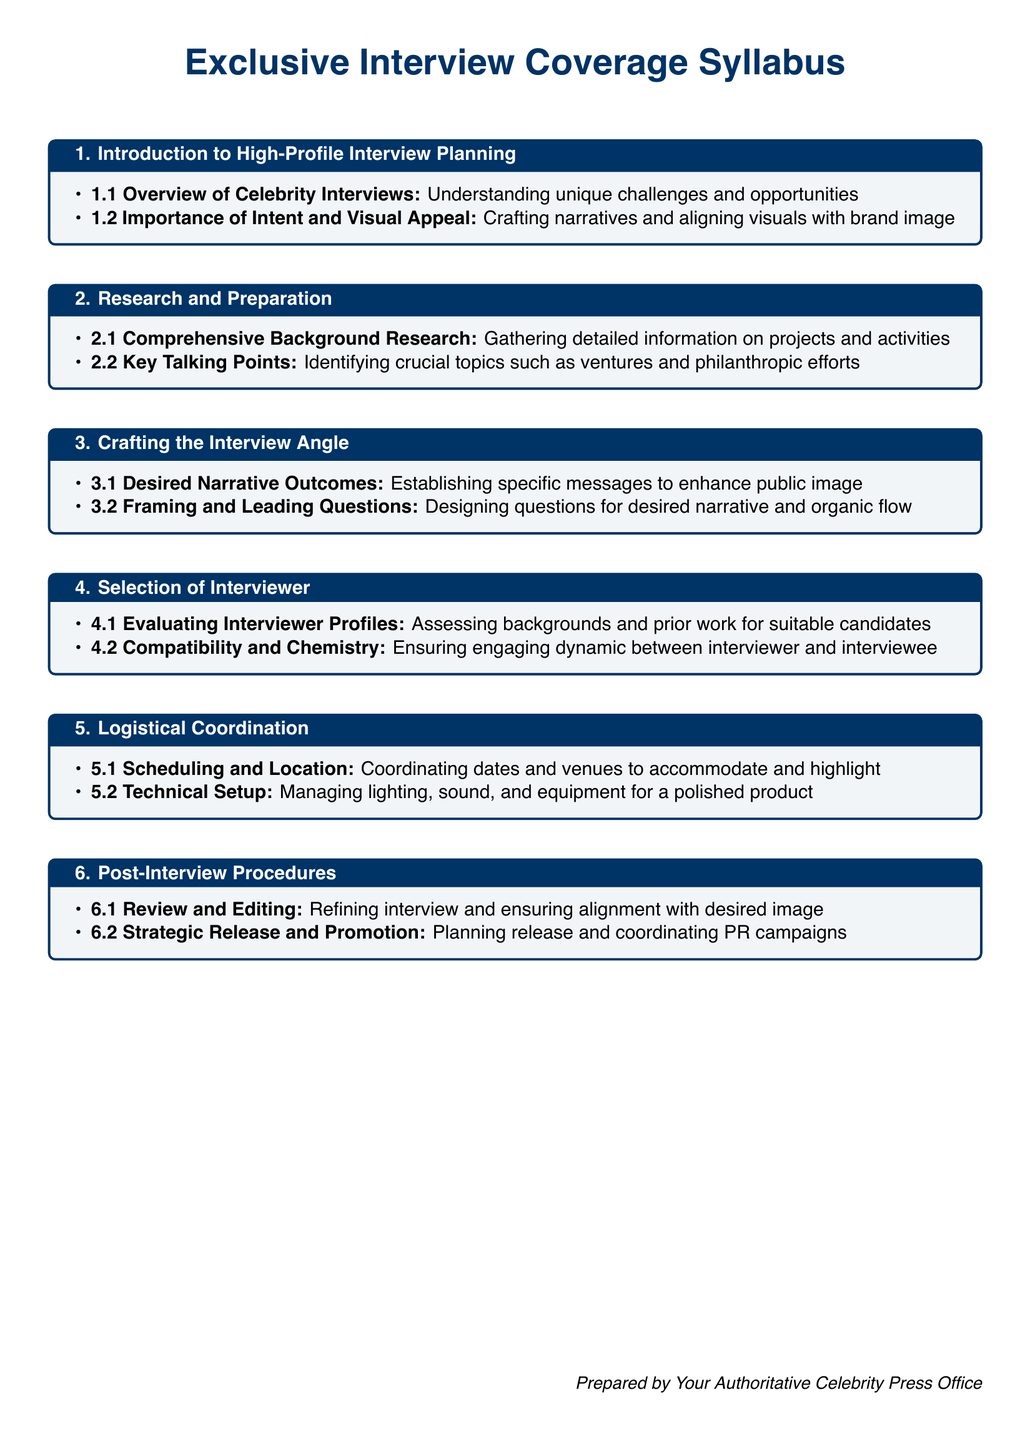What is the title of the syllabus? The title of the syllabus is presented at the beginning of the document, emphasizing its focus on exclusive interview coverage.
Answer: Exclusive Interview Coverage Syllabus What is the color used for section titles? The color specified for section titles is mentioned in the formatting section of the document.
Answer: Deep blue How many main sections are in the syllabus? The number of main sections can be counted by referencing the main headings in the document.
Answer: Six What does section 2.1 focus on? The specific focus of section 2.1 is outlined as preparing for interviews.
Answer: Comprehensive Background Research What is a key element of section 3.2? The essential content in section 3.2 centers on a particular interviewing technique, as listed in the syllabus.
Answer: Framing and Leading Questions Which aspect does section 5.2 address? Section 5.2 specifically discusses an important technical consideration for interviews.
Answer: Technical Setup What topic does section 6.1 cover? The content of section 6.1 revolves around an essential part of the post-interview process.
Answer: Review and Editing What is the purpose of including desired narrative outcomes? This purpose can be deduced from the definition of desired narrative outcomes in section 3.1.
Answer: Enhancing public image What is emphasized in section 4.2? The key point in section 4.2 highlights a crucial interpersonal factor regarding interview dynamics.
Answer: Compatibility and Chemistry 